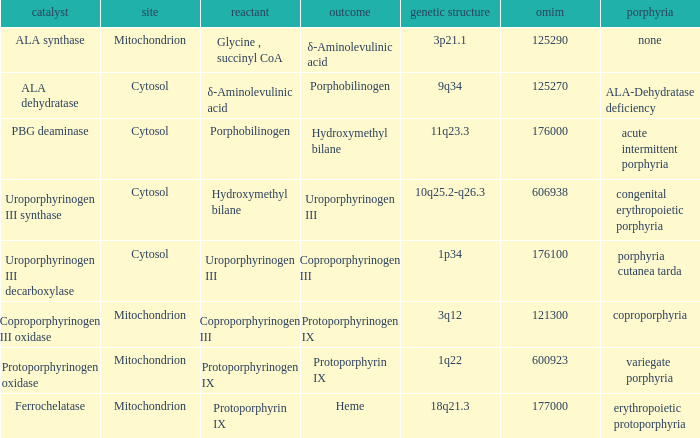What is the location of the enzyme Uroporphyrinogen iii Synthase? Cytosol. 